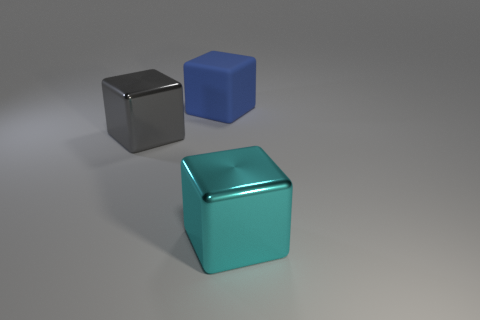Add 1 large gray metal cubes. How many objects exist? 4 Add 1 big gray metallic things. How many big gray metallic things exist? 2 Subtract 0 gray balls. How many objects are left? 3 Subtract all blue objects. Subtract all big cyan objects. How many objects are left? 1 Add 2 cyan blocks. How many cyan blocks are left? 3 